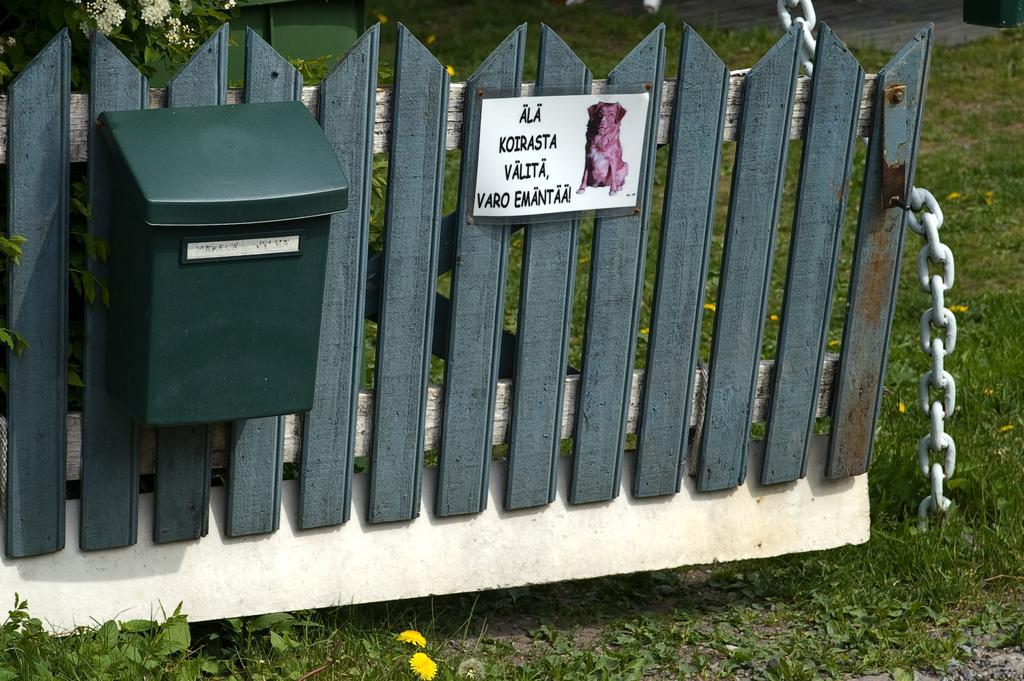Could you give a brief overview of what you see in this image? In this picture I can see fence, board, mailbox, chain, grass, plants, flowers. 